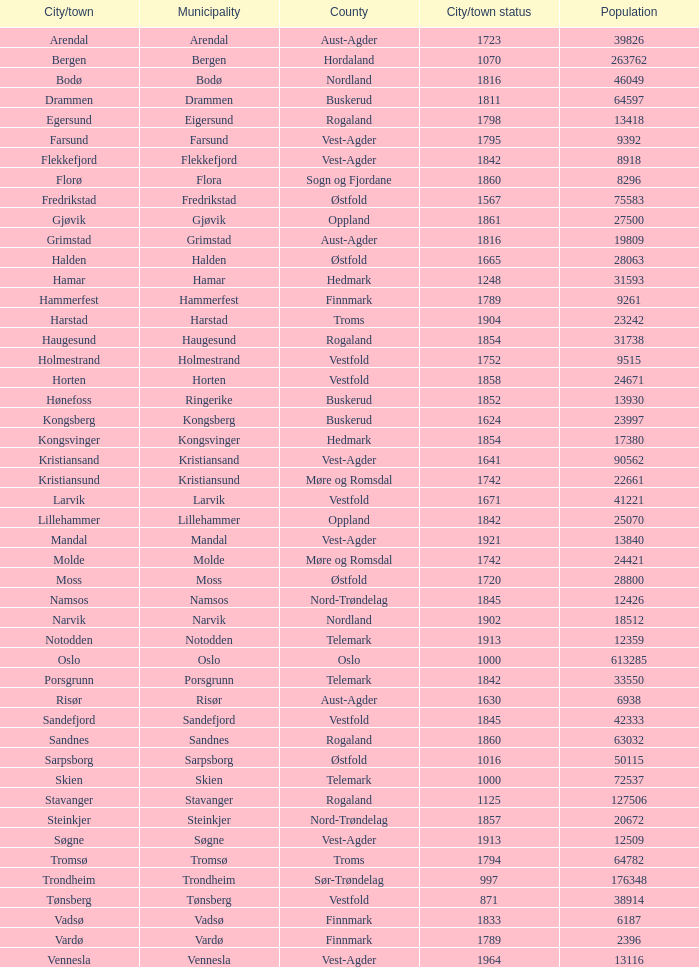In the city/town of arendal, what is the entire population count? 1.0. 